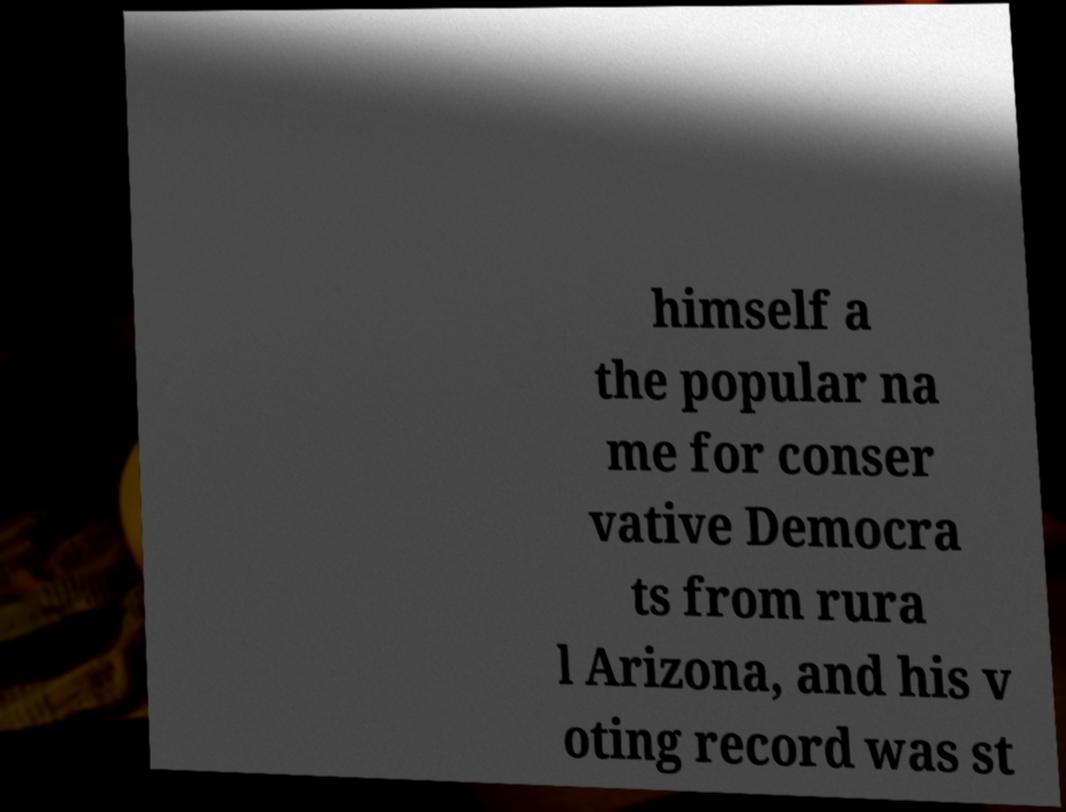There's text embedded in this image that I need extracted. Can you transcribe it verbatim? himself a the popular na me for conser vative Democra ts from rura l Arizona, and his v oting record was st 